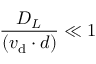<formula> <loc_0><loc_0><loc_500><loc_500>\frac { D _ { L } } { ( v _ { d } \cdot d ) } \ll 1</formula> 